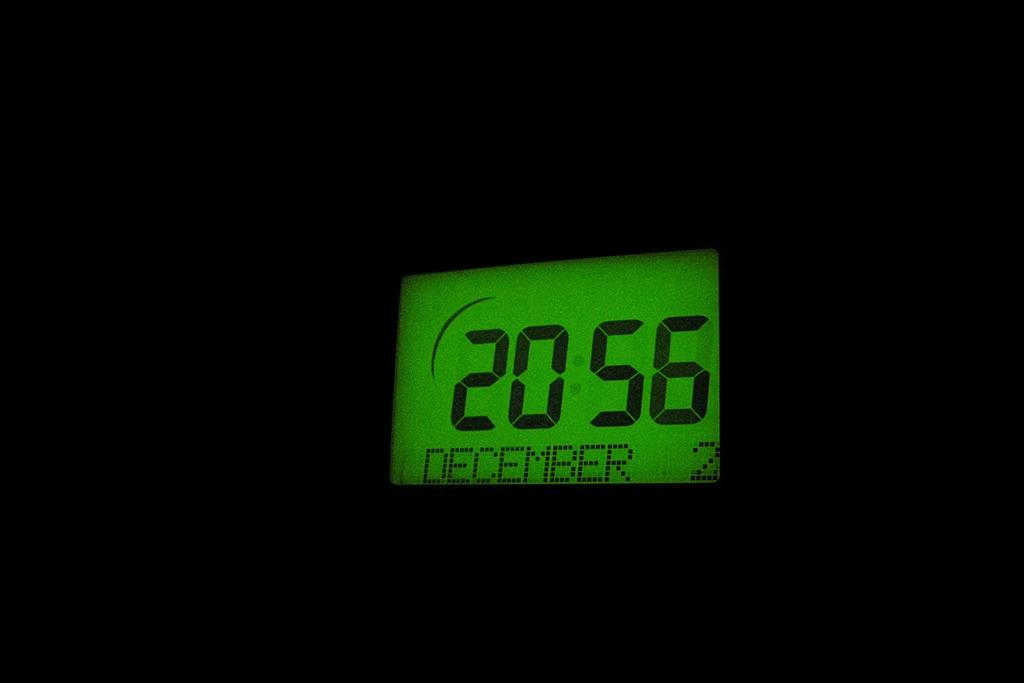<image>
Create a compact narrative representing the image presented. Digital clock dated December 2. The time is 20:56. 